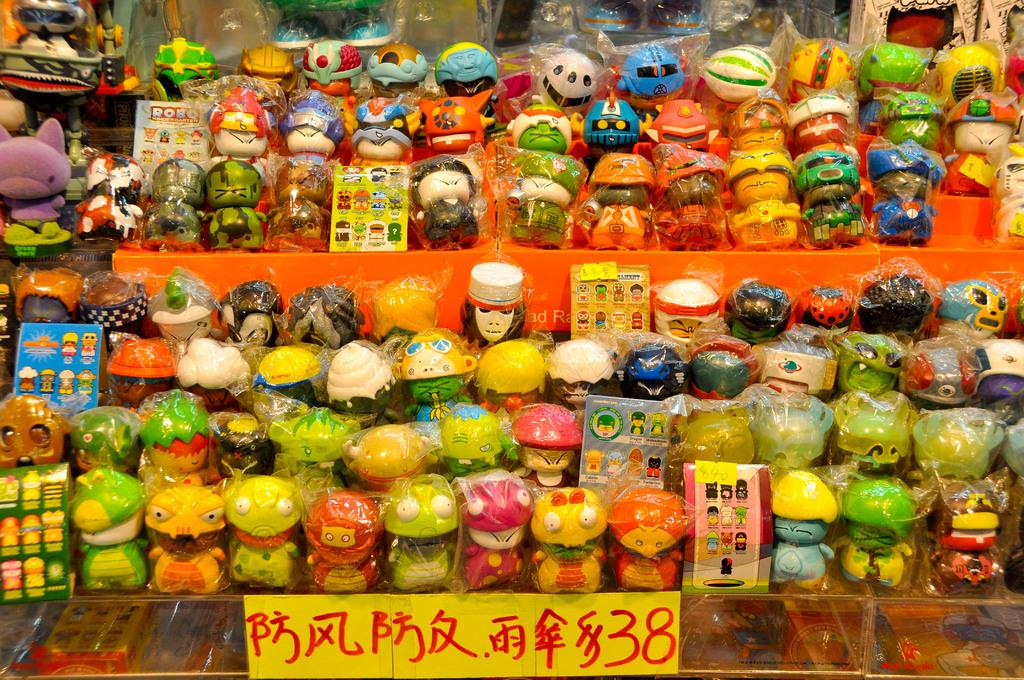<image>
Describe the image concisely. An asian display with the price of $38 at the front of the items. 